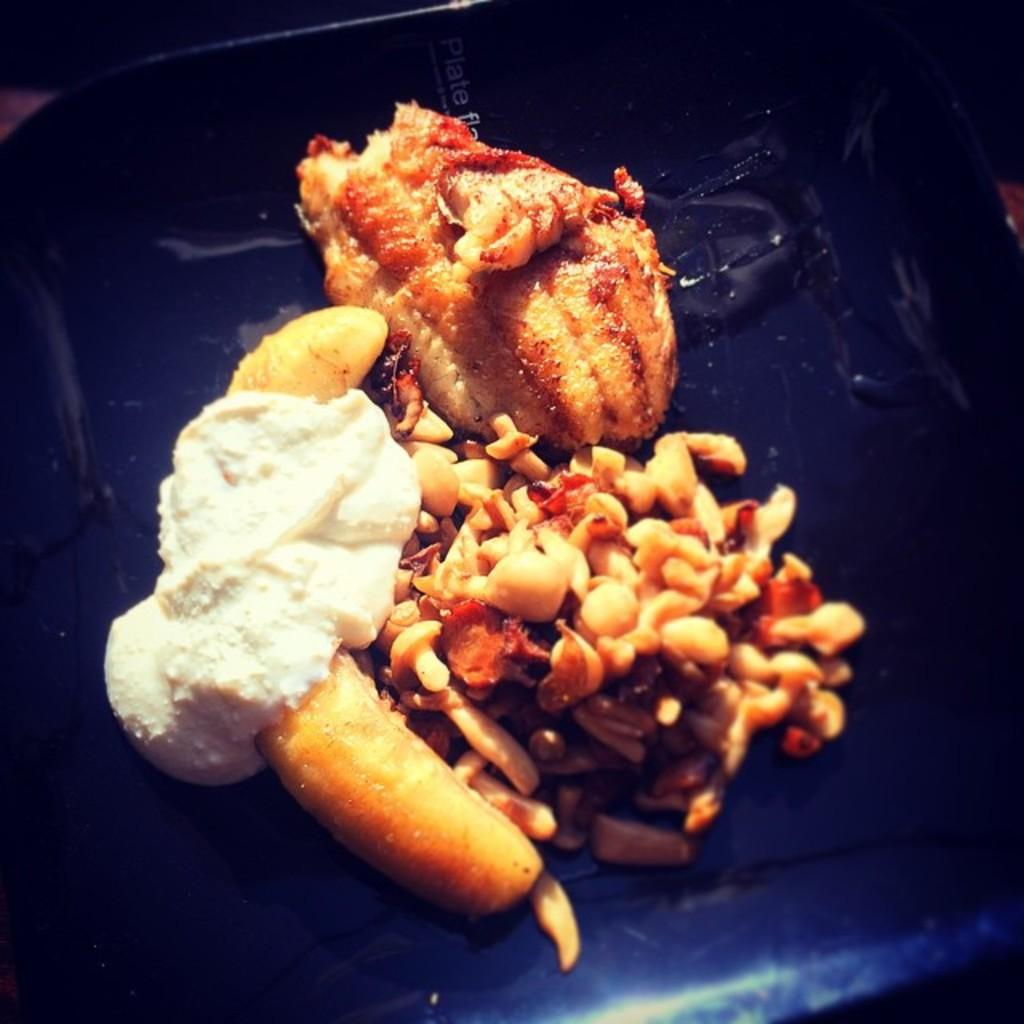What type of food can be seen in the image? There are cooked food items in the image. Can you describe one of the food items in more detail? One of the food items is topped with cream on the left side. What type of paper can be seen in the image? There is no paper present in the image; it only features cooked food items. 